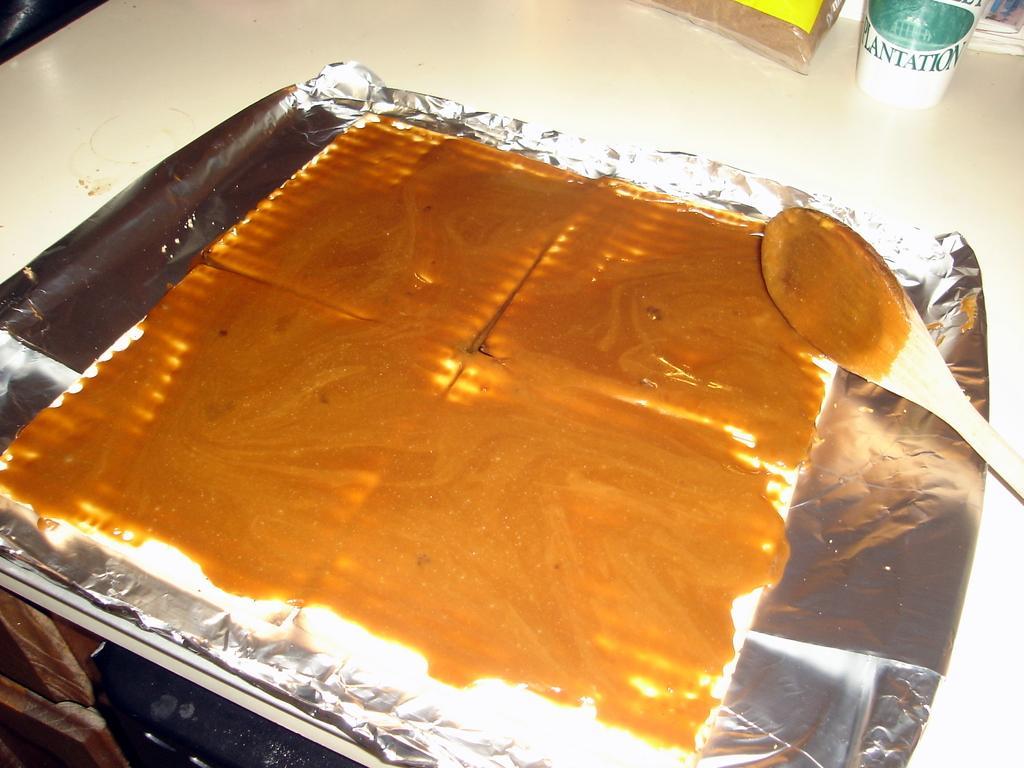Can you describe this image briefly? In this image I can see the food on the silver color aluminum foil. To the side I can see the packet and the white and green color object. These are on the cream color surface. 